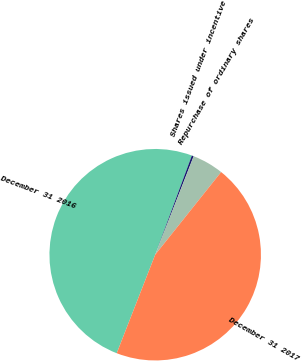Convert chart. <chart><loc_0><loc_0><loc_500><loc_500><pie_chart><fcel>December 31 2016<fcel>Shares issued under incentive<fcel>Repurchase of ordinary shares<fcel>December 31 2017<nl><fcel>49.71%<fcel>0.29%<fcel>4.79%<fcel>45.21%<nl></chart> 